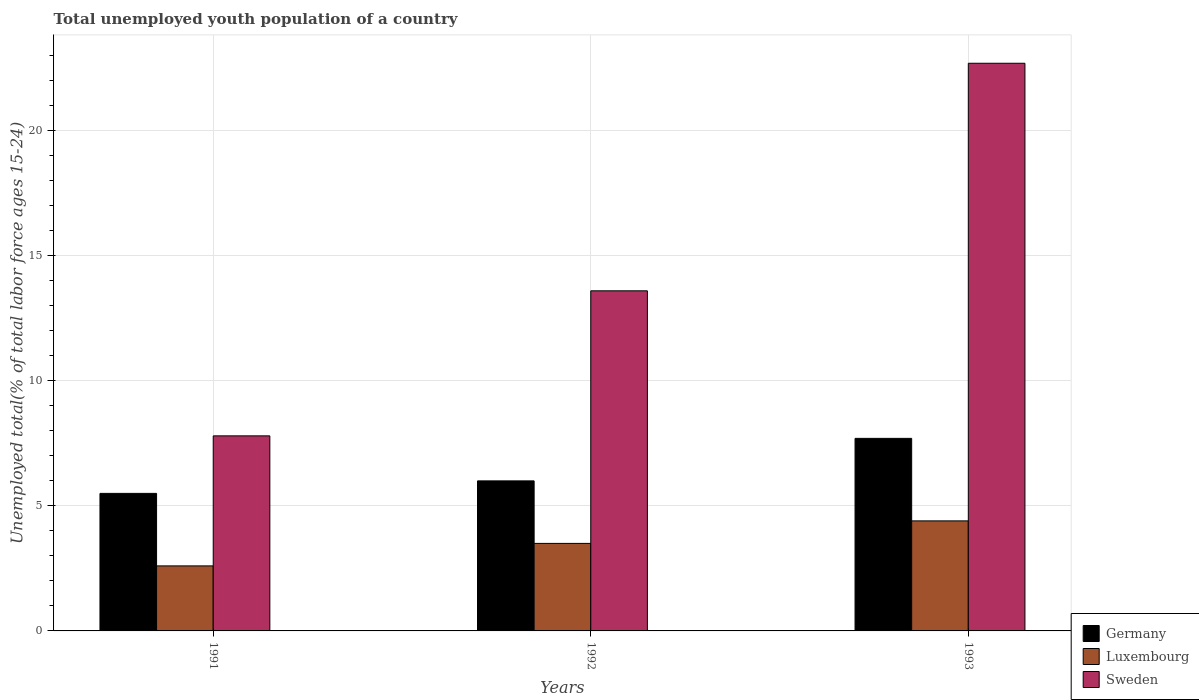Are the number of bars per tick equal to the number of legend labels?
Your answer should be compact. Yes. What is the label of the 3rd group of bars from the left?
Provide a succinct answer. 1993. What is the percentage of total unemployed youth population of a country in Sweden in 1993?
Your answer should be very brief. 22.7. Across all years, what is the maximum percentage of total unemployed youth population of a country in Germany?
Keep it short and to the point. 7.7. Across all years, what is the minimum percentage of total unemployed youth population of a country in Sweden?
Provide a short and direct response. 7.8. In which year was the percentage of total unemployed youth population of a country in Sweden minimum?
Your answer should be compact. 1991. What is the total percentage of total unemployed youth population of a country in Sweden in the graph?
Give a very brief answer. 44.1. What is the difference between the percentage of total unemployed youth population of a country in Germany in 1991 and that in 1993?
Your answer should be very brief. -2.2. What is the difference between the percentage of total unemployed youth population of a country in Sweden in 1992 and the percentage of total unemployed youth population of a country in Germany in 1991?
Provide a succinct answer. 8.1. What is the average percentage of total unemployed youth population of a country in Sweden per year?
Your response must be concise. 14.7. In the year 1991, what is the difference between the percentage of total unemployed youth population of a country in Luxembourg and percentage of total unemployed youth population of a country in Sweden?
Your response must be concise. -5.2. What is the ratio of the percentage of total unemployed youth population of a country in Sweden in 1992 to that in 1993?
Offer a very short reply. 0.6. Is the difference between the percentage of total unemployed youth population of a country in Luxembourg in 1992 and 1993 greater than the difference between the percentage of total unemployed youth population of a country in Sweden in 1992 and 1993?
Your response must be concise. Yes. What is the difference between the highest and the second highest percentage of total unemployed youth population of a country in Luxembourg?
Your answer should be very brief. 0.9. What is the difference between the highest and the lowest percentage of total unemployed youth population of a country in Germany?
Offer a terse response. 2.2. Is it the case that in every year, the sum of the percentage of total unemployed youth population of a country in Luxembourg and percentage of total unemployed youth population of a country in Sweden is greater than the percentage of total unemployed youth population of a country in Germany?
Provide a succinct answer. Yes. What is the difference between two consecutive major ticks on the Y-axis?
Provide a succinct answer. 5. Are the values on the major ticks of Y-axis written in scientific E-notation?
Ensure brevity in your answer.  No. Does the graph contain grids?
Ensure brevity in your answer.  Yes. Where does the legend appear in the graph?
Offer a very short reply. Bottom right. How are the legend labels stacked?
Provide a succinct answer. Vertical. What is the title of the graph?
Give a very brief answer. Total unemployed youth population of a country. Does "World" appear as one of the legend labels in the graph?
Your answer should be very brief. No. What is the label or title of the X-axis?
Your answer should be very brief. Years. What is the label or title of the Y-axis?
Offer a terse response. Unemployed total(% of total labor force ages 15-24). What is the Unemployed total(% of total labor force ages 15-24) of Germany in 1991?
Your answer should be compact. 5.5. What is the Unemployed total(% of total labor force ages 15-24) in Luxembourg in 1991?
Your answer should be compact. 2.6. What is the Unemployed total(% of total labor force ages 15-24) in Sweden in 1991?
Offer a terse response. 7.8. What is the Unemployed total(% of total labor force ages 15-24) in Luxembourg in 1992?
Your response must be concise. 3.5. What is the Unemployed total(% of total labor force ages 15-24) in Sweden in 1992?
Ensure brevity in your answer.  13.6. What is the Unemployed total(% of total labor force ages 15-24) in Germany in 1993?
Offer a terse response. 7.7. What is the Unemployed total(% of total labor force ages 15-24) of Luxembourg in 1993?
Provide a short and direct response. 4.4. What is the Unemployed total(% of total labor force ages 15-24) in Sweden in 1993?
Make the answer very short. 22.7. Across all years, what is the maximum Unemployed total(% of total labor force ages 15-24) of Germany?
Offer a very short reply. 7.7. Across all years, what is the maximum Unemployed total(% of total labor force ages 15-24) in Luxembourg?
Your response must be concise. 4.4. Across all years, what is the maximum Unemployed total(% of total labor force ages 15-24) of Sweden?
Your answer should be compact. 22.7. Across all years, what is the minimum Unemployed total(% of total labor force ages 15-24) of Luxembourg?
Provide a short and direct response. 2.6. Across all years, what is the minimum Unemployed total(% of total labor force ages 15-24) in Sweden?
Offer a very short reply. 7.8. What is the total Unemployed total(% of total labor force ages 15-24) of Germany in the graph?
Keep it short and to the point. 19.2. What is the total Unemployed total(% of total labor force ages 15-24) of Sweden in the graph?
Your answer should be very brief. 44.1. What is the difference between the Unemployed total(% of total labor force ages 15-24) in Luxembourg in 1991 and that in 1992?
Make the answer very short. -0.9. What is the difference between the Unemployed total(% of total labor force ages 15-24) of Sweden in 1991 and that in 1992?
Offer a terse response. -5.8. What is the difference between the Unemployed total(% of total labor force ages 15-24) in Germany in 1991 and that in 1993?
Your answer should be compact. -2.2. What is the difference between the Unemployed total(% of total labor force ages 15-24) of Luxembourg in 1991 and that in 1993?
Ensure brevity in your answer.  -1.8. What is the difference between the Unemployed total(% of total labor force ages 15-24) of Sweden in 1991 and that in 1993?
Provide a succinct answer. -14.9. What is the difference between the Unemployed total(% of total labor force ages 15-24) of Germany in 1992 and that in 1993?
Keep it short and to the point. -1.7. What is the difference between the Unemployed total(% of total labor force ages 15-24) in Sweden in 1992 and that in 1993?
Your response must be concise. -9.1. What is the difference between the Unemployed total(% of total labor force ages 15-24) of Germany in 1991 and the Unemployed total(% of total labor force ages 15-24) of Luxembourg in 1992?
Give a very brief answer. 2. What is the difference between the Unemployed total(% of total labor force ages 15-24) in Germany in 1991 and the Unemployed total(% of total labor force ages 15-24) in Sweden in 1992?
Offer a terse response. -8.1. What is the difference between the Unemployed total(% of total labor force ages 15-24) of Germany in 1991 and the Unemployed total(% of total labor force ages 15-24) of Luxembourg in 1993?
Keep it short and to the point. 1.1. What is the difference between the Unemployed total(% of total labor force ages 15-24) in Germany in 1991 and the Unemployed total(% of total labor force ages 15-24) in Sweden in 1993?
Keep it short and to the point. -17.2. What is the difference between the Unemployed total(% of total labor force ages 15-24) in Luxembourg in 1991 and the Unemployed total(% of total labor force ages 15-24) in Sweden in 1993?
Offer a terse response. -20.1. What is the difference between the Unemployed total(% of total labor force ages 15-24) in Germany in 1992 and the Unemployed total(% of total labor force ages 15-24) in Sweden in 1993?
Your answer should be very brief. -16.7. What is the difference between the Unemployed total(% of total labor force ages 15-24) in Luxembourg in 1992 and the Unemployed total(% of total labor force ages 15-24) in Sweden in 1993?
Ensure brevity in your answer.  -19.2. What is the average Unemployed total(% of total labor force ages 15-24) in Luxembourg per year?
Your response must be concise. 3.5. What is the average Unemployed total(% of total labor force ages 15-24) of Sweden per year?
Provide a succinct answer. 14.7. In the year 1991, what is the difference between the Unemployed total(% of total labor force ages 15-24) of Germany and Unemployed total(% of total labor force ages 15-24) of Sweden?
Keep it short and to the point. -2.3. In the year 1992, what is the difference between the Unemployed total(% of total labor force ages 15-24) in Germany and Unemployed total(% of total labor force ages 15-24) in Luxembourg?
Offer a terse response. 2.5. In the year 1992, what is the difference between the Unemployed total(% of total labor force ages 15-24) of Germany and Unemployed total(% of total labor force ages 15-24) of Sweden?
Offer a terse response. -7.6. In the year 1993, what is the difference between the Unemployed total(% of total labor force ages 15-24) of Germany and Unemployed total(% of total labor force ages 15-24) of Sweden?
Provide a succinct answer. -15. In the year 1993, what is the difference between the Unemployed total(% of total labor force ages 15-24) of Luxembourg and Unemployed total(% of total labor force ages 15-24) of Sweden?
Make the answer very short. -18.3. What is the ratio of the Unemployed total(% of total labor force ages 15-24) of Luxembourg in 1991 to that in 1992?
Offer a terse response. 0.74. What is the ratio of the Unemployed total(% of total labor force ages 15-24) of Sweden in 1991 to that in 1992?
Give a very brief answer. 0.57. What is the ratio of the Unemployed total(% of total labor force ages 15-24) of Germany in 1991 to that in 1993?
Ensure brevity in your answer.  0.71. What is the ratio of the Unemployed total(% of total labor force ages 15-24) in Luxembourg in 1991 to that in 1993?
Give a very brief answer. 0.59. What is the ratio of the Unemployed total(% of total labor force ages 15-24) in Sweden in 1991 to that in 1993?
Provide a succinct answer. 0.34. What is the ratio of the Unemployed total(% of total labor force ages 15-24) of Germany in 1992 to that in 1993?
Provide a short and direct response. 0.78. What is the ratio of the Unemployed total(% of total labor force ages 15-24) in Luxembourg in 1992 to that in 1993?
Keep it short and to the point. 0.8. What is the ratio of the Unemployed total(% of total labor force ages 15-24) in Sweden in 1992 to that in 1993?
Offer a very short reply. 0.6. What is the difference between the highest and the second highest Unemployed total(% of total labor force ages 15-24) of Germany?
Your answer should be compact. 1.7. What is the difference between the highest and the second highest Unemployed total(% of total labor force ages 15-24) in Luxembourg?
Ensure brevity in your answer.  0.9. What is the difference between the highest and the second highest Unemployed total(% of total labor force ages 15-24) of Sweden?
Your answer should be compact. 9.1. What is the difference between the highest and the lowest Unemployed total(% of total labor force ages 15-24) in Luxembourg?
Offer a terse response. 1.8. 